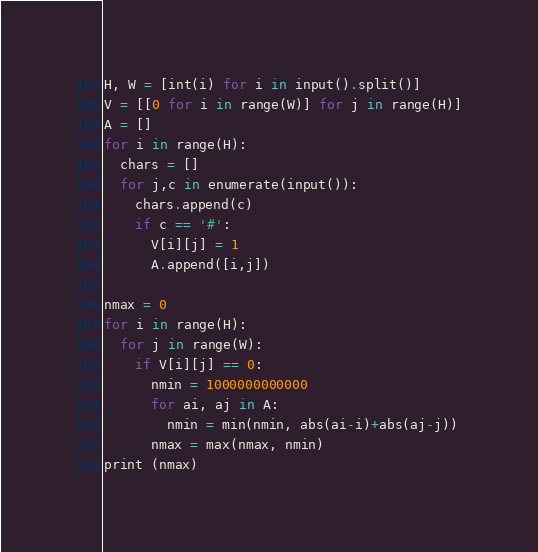<code> <loc_0><loc_0><loc_500><loc_500><_Python_>H, W = [int(i) for i in input().split()]
V = [[0 for i in range(W)] for j in range(H)]
A = []
for i in range(H):
  chars = []
  for j,c in enumerate(input()):
    chars.append(c)
    if c == '#':
      V[i][j] = 1
      A.append([i,j])

nmax = 0
for i in range(H):
  for j in range(W):
    if V[i][j] == 0:
      nmin = 1000000000000
      for ai, aj in A:
        nmin = min(nmin, abs(ai-i)+abs(aj-j))
      nmax = max(nmax, nmin)
print (nmax)</code> 